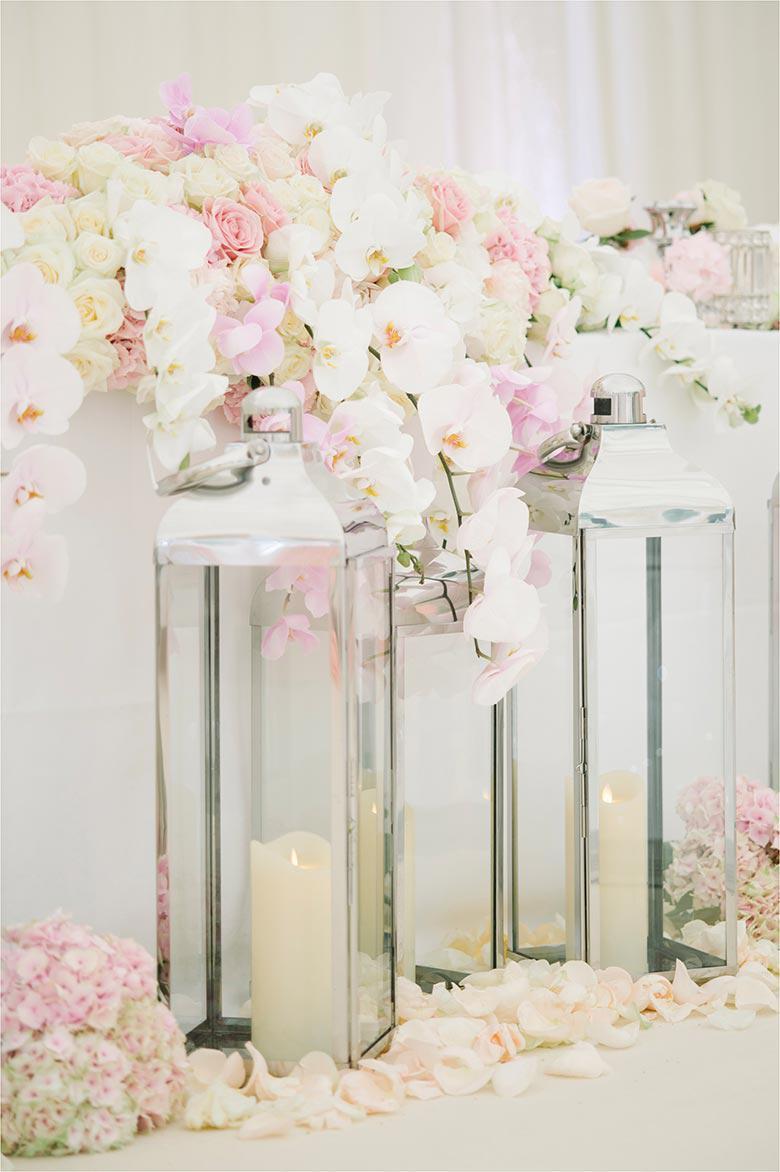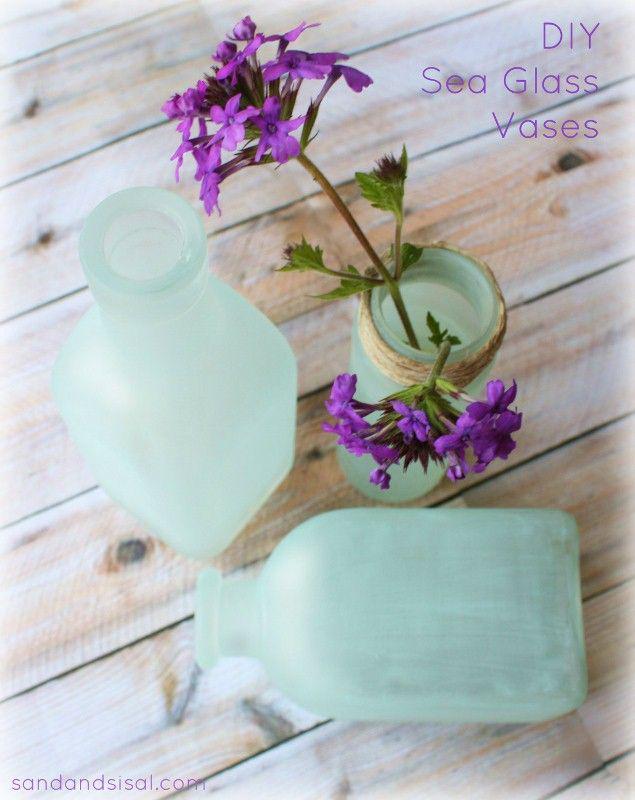The first image is the image on the left, the second image is the image on the right. For the images displayed, is the sentence "There is at least two vases in the right image." factually correct? Answer yes or no. Yes. The first image is the image on the left, the second image is the image on the right. Given the left and right images, does the statement "An image shows a pair of vases designed with a curl shape at the bottom." hold true? Answer yes or no. No. 